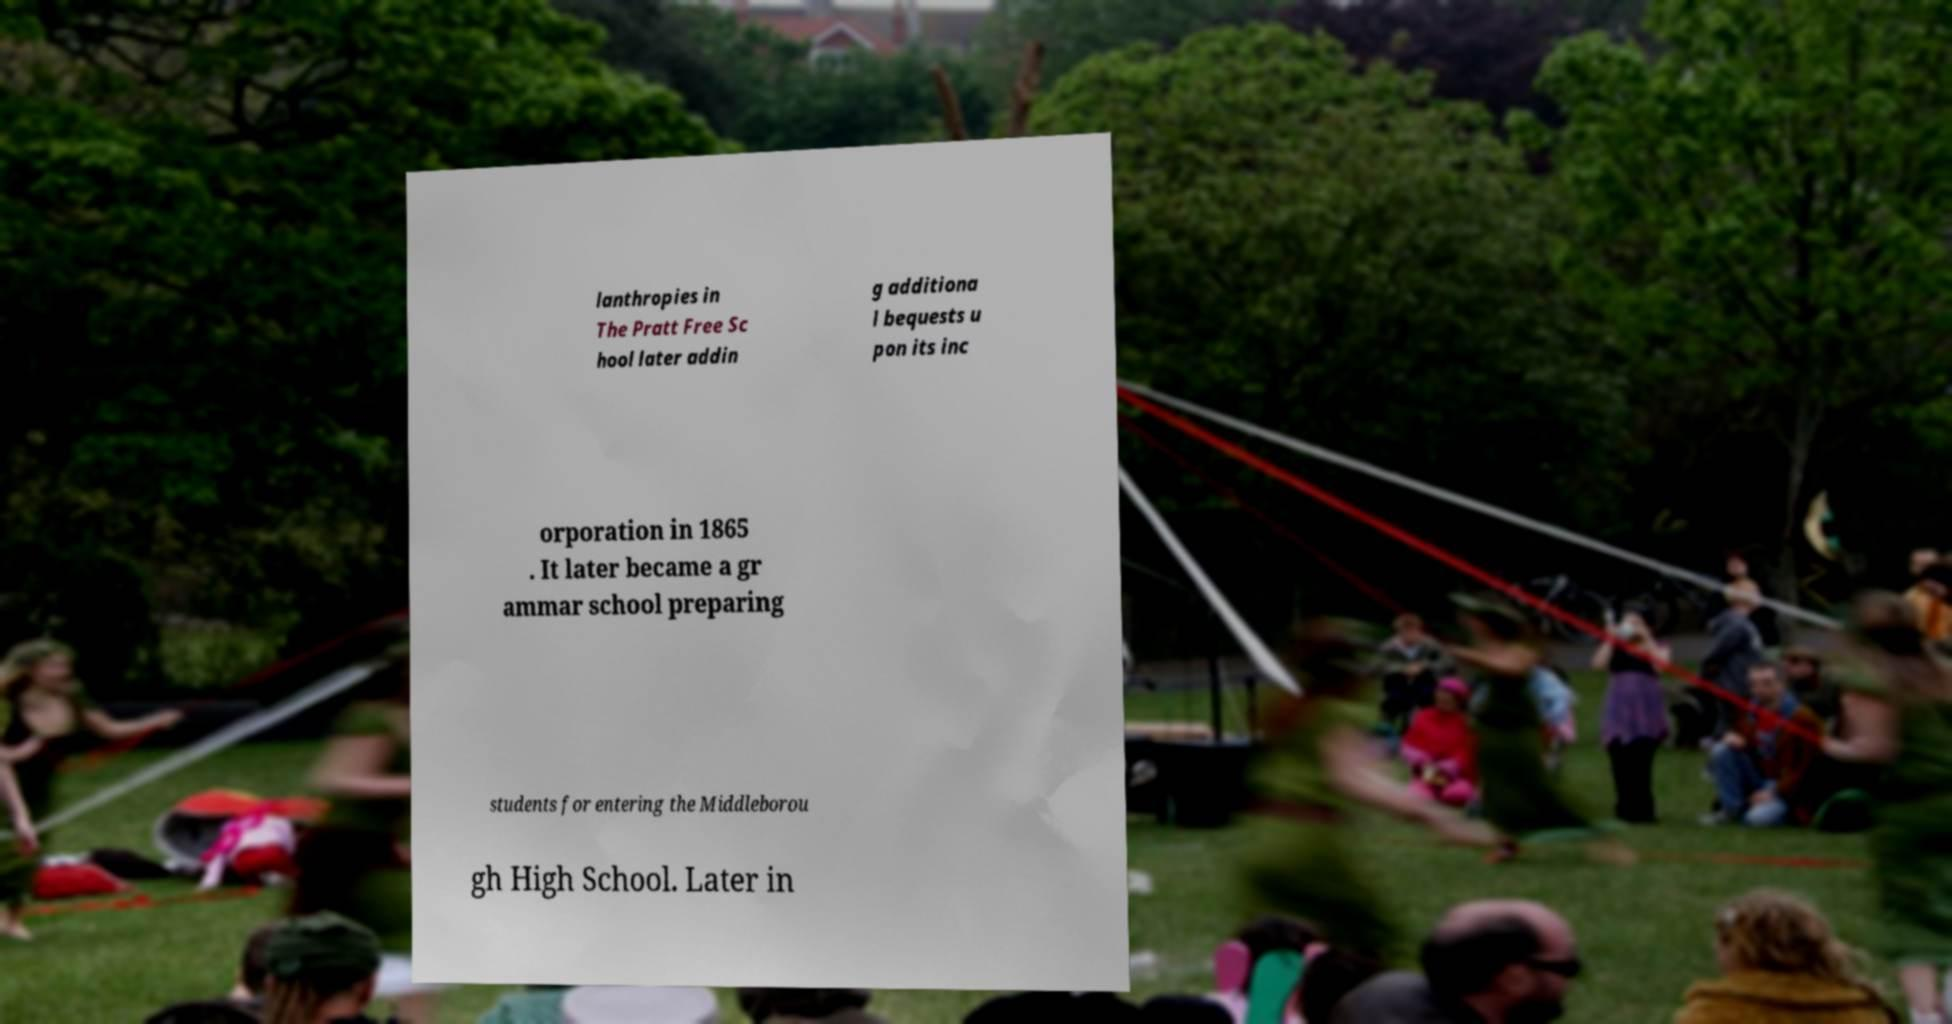There's text embedded in this image that I need extracted. Can you transcribe it verbatim? lanthropies in The Pratt Free Sc hool later addin g additiona l bequests u pon its inc orporation in 1865 . It later became a gr ammar school preparing students for entering the Middleborou gh High School. Later in 